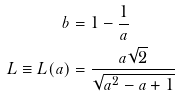<formula> <loc_0><loc_0><loc_500><loc_500>b & = 1 - \frac { 1 } { a } \\ L \equiv L ( a ) & = \frac { a \sqrt { 2 } } { \sqrt { a ^ { 2 } - a + 1 } }</formula> 